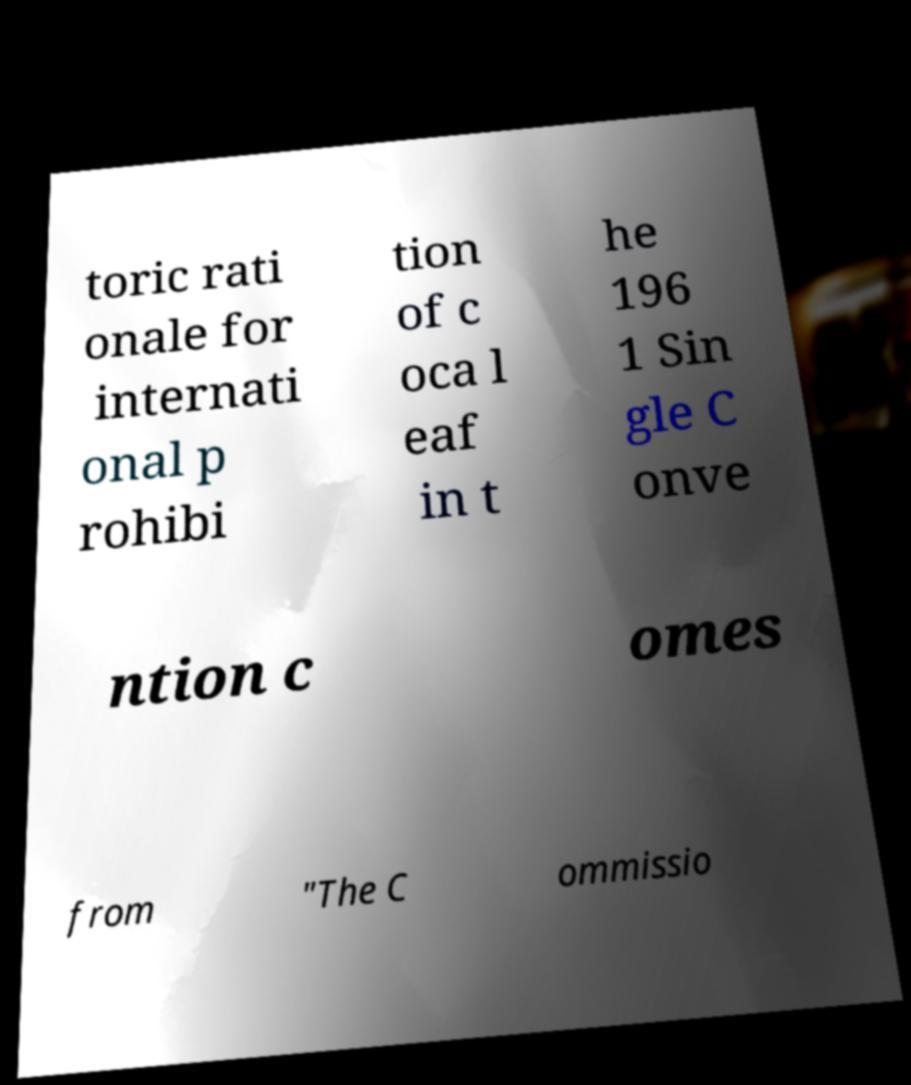Could you assist in decoding the text presented in this image and type it out clearly? toric rati onale for internati onal p rohibi tion of c oca l eaf in t he 196 1 Sin gle C onve ntion c omes from "The C ommissio 